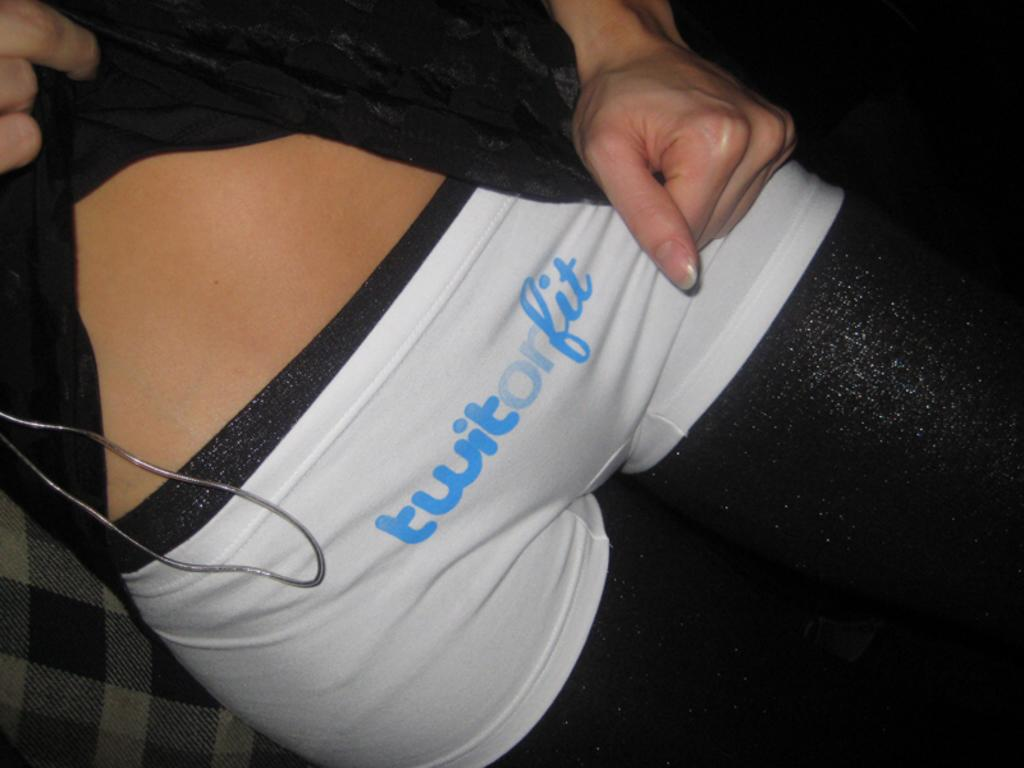<image>
Present a compact description of the photo's key features. a person showing off white shorts with the words Twit or Fit on them 